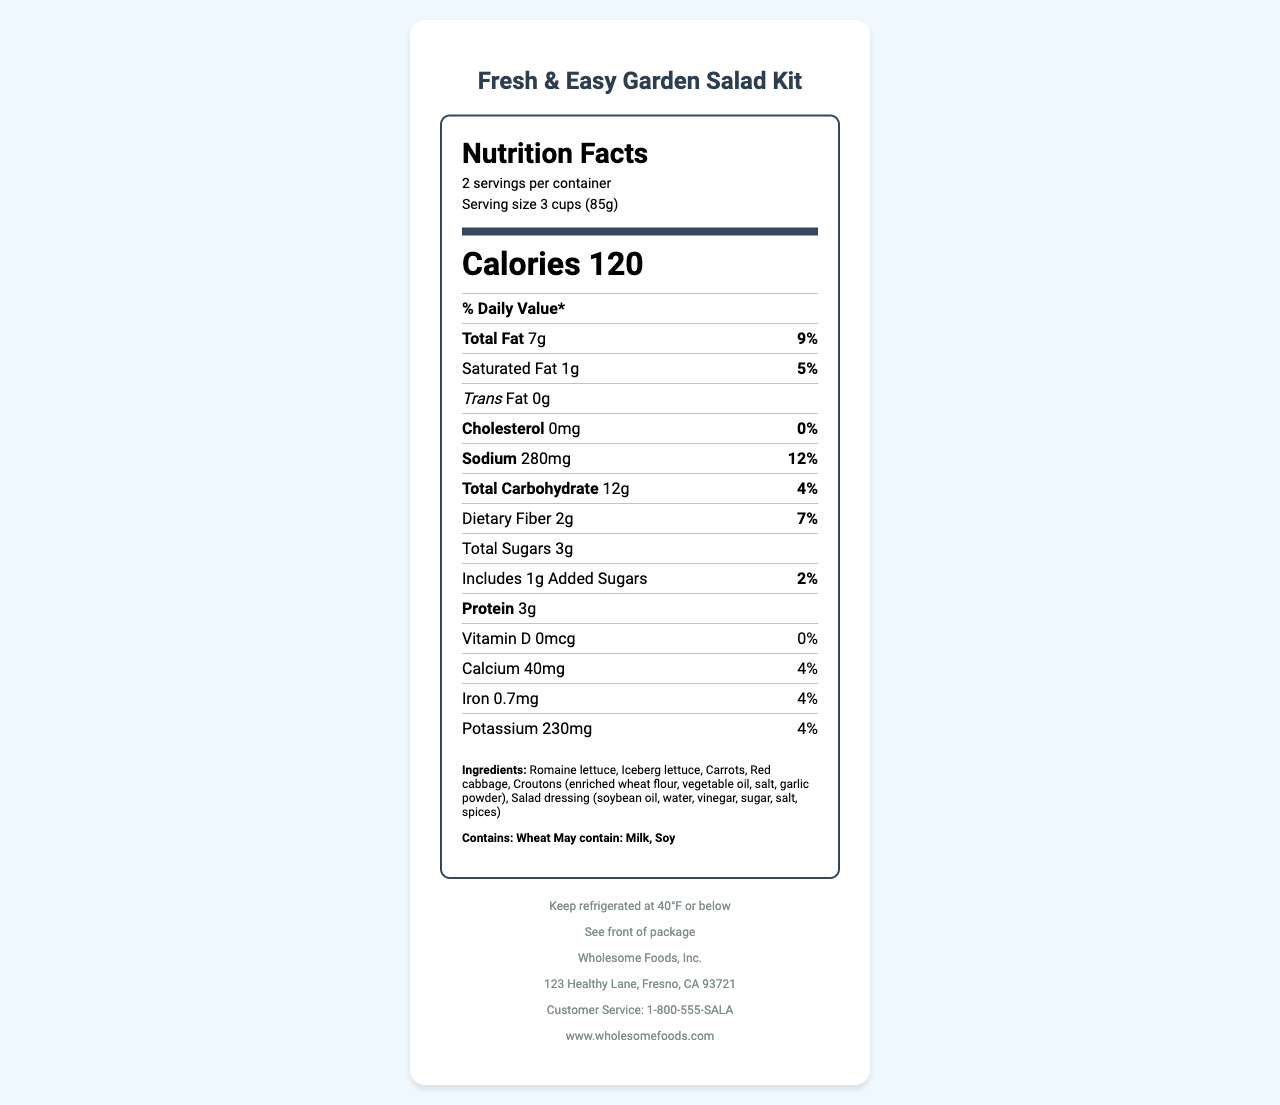what is the product name? The title at the top of the document indicates that the product name is "Fresh & Easy Garden Salad Kit."
Answer: Fresh & Easy Garden Salad Kit how many servings are in one container? The "Nutrition Facts" section of the document specifies that there are 2 servings per container.
Answer: 2 servings how many calories are there per serving? The "Calories" section of the document indicates that each serving contains 120 calories.
Answer: 120 calories what is the serving size? The "serving size" is noted in the "Nutrition Facts" section as 3 cups or 85 grams.
Answer: 3 cups (85g) what is the total amount of fat per serving? The amount of total fat per serving is listed as 7 grams in the "Nutrition Facts" section.
Answer: 7g what is the percent daily value of sodium in each serving? The "Nutrition Facts" section lists the percent daily value of sodium per serving as 12%.
Answer: 12% which of the following ingredients is not mentioned in the salad kit? A. Romaine lettuce B. Carrots C. Croutons D. Avocado The ingredients listed in the document are Romaine lettuce, Iceberg lettuce, Carrots, Red cabbage, Croutons, and Salad dressing. Avocado is not mentioned.
Answer: D. Avocado what are the possible allergens mentioned? The Allergens section of the document states that the product contains wheat and may contain milk and soy.
Answer: Wheat, Milk, Soy True or False: There is no cholesterol in this product. The "Cholesterol" section shows that there is 0 mg of cholesterol, which means there is no cholesterol in the product.
Answer: True what are the main nutrients included in the salad kit? The main nutrients included are listed under the "Nutrition Facts" section in terms of quantity and daily value.
Answer: Total Fat, Saturated Fat, Trans Fat, Cholesterol, Sodium, Total Carbohydrate, Dietary Fiber, Total Sugars, Protein, Vitamin D, Calcium, Iron, Potassium how should the salad kit be stored? The document specifies the storage instructions as "Keep refrigerated at 40°F or below."
Answer: Keep refrigerated at 40°F or below what is the manufacturer’s address? The document’s footer provides the manufacturer's address as "123 Healthy Lane, Fresno, CA 93721."
Answer: 123 Healthy Lane, Fresno, CA 93721 summarize the main idea of the document. The document outlines nutritional statistics such as serving size, calories per serving, fat content, and more. It also includes the ingredients, allergens, storage instructions, manufacturer details, and customer service information.
Answer: The document provides detailed nutritional information and other essential details about the Fresh & Easy Garden Salad Kit, including serving size, calories, ingredients, allergens, and storage instructions. what is the price of this salad kit? The document does not provide any information about the price of the product, so the price cannot be determined based on the visual information available.
Answer: Cannot be determined 